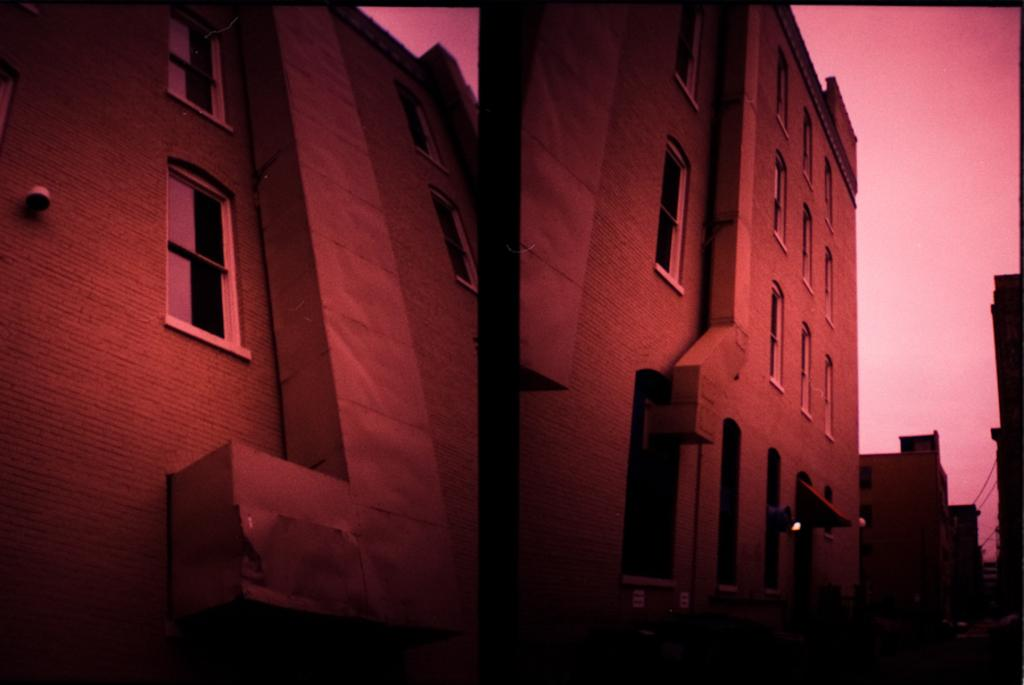What type of artwork is the image? The image is a collage of two images. What can be seen in the images? There are buildings in the images. What is visible at the top of the images? The sky is visible at the top of the images. What architectural feature is present in the buildings? There are windows in the buildings. How many goldfish can be seen swimming in the sky in the image? There are no goldfish present in the image; the sky is visible but does not contain any goldfish. 